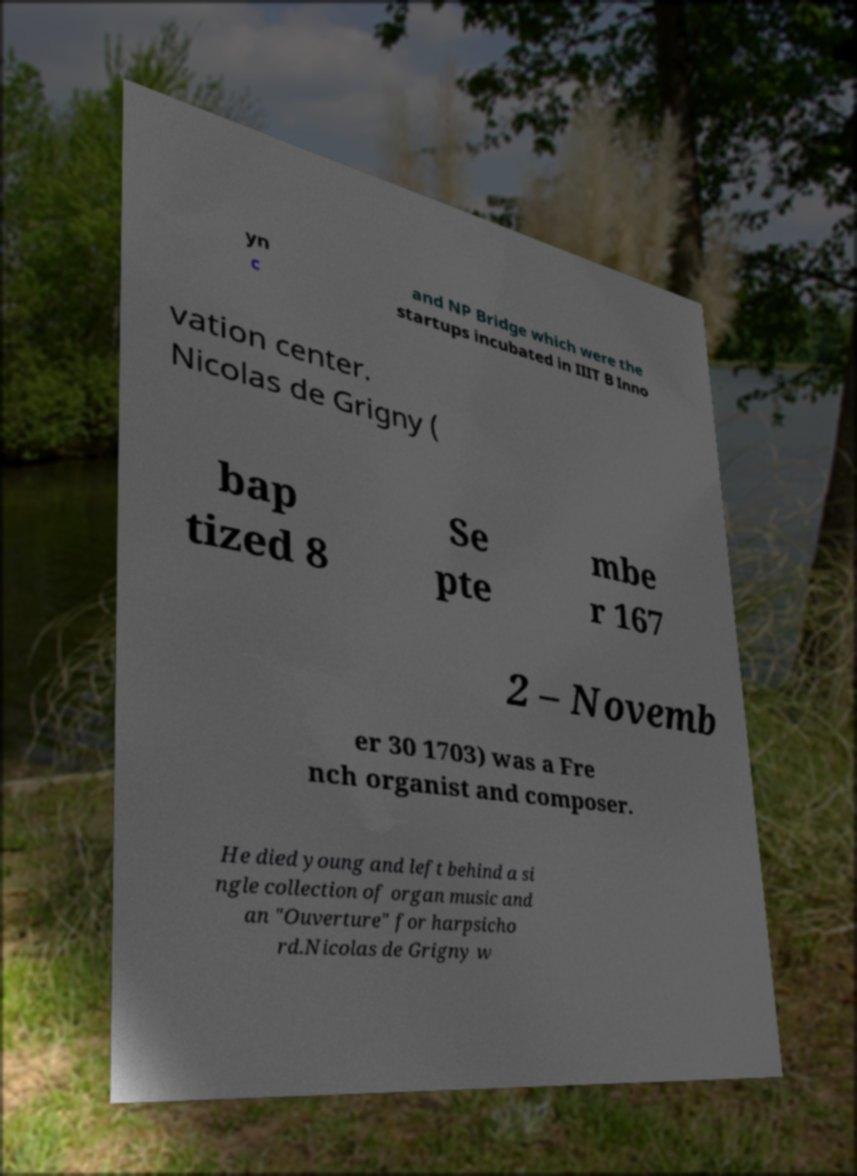Please read and relay the text visible in this image. What does it say? yn c and NP Bridge which were the startups incubated in IIIT B Inno vation center. Nicolas de Grigny ( bap tized 8 Se pte mbe r 167 2 – Novemb er 30 1703) was a Fre nch organist and composer. He died young and left behind a si ngle collection of organ music and an "Ouverture" for harpsicho rd.Nicolas de Grigny w 